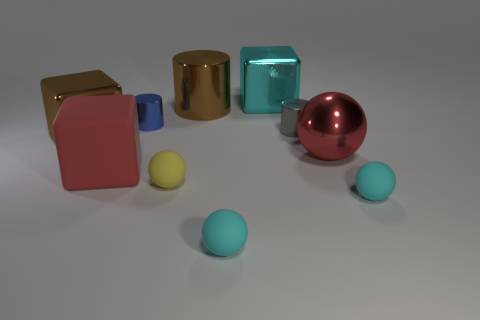Subtract all tiny cylinders. How many cylinders are left? 1 Subtract 2 spheres. How many spheres are left? 2 Subtract all red cubes. How many cubes are left? 2 Subtract all cylinders. How many objects are left? 7 Subtract all blue blocks. How many yellow balls are left? 1 Subtract all blue shiny cylinders. Subtract all cyan spheres. How many objects are left? 7 Add 2 cyan things. How many cyan things are left? 5 Add 7 small gray metal balls. How many small gray metal balls exist? 7 Subtract 0 purple balls. How many objects are left? 10 Subtract all red blocks. Subtract all yellow cylinders. How many blocks are left? 2 